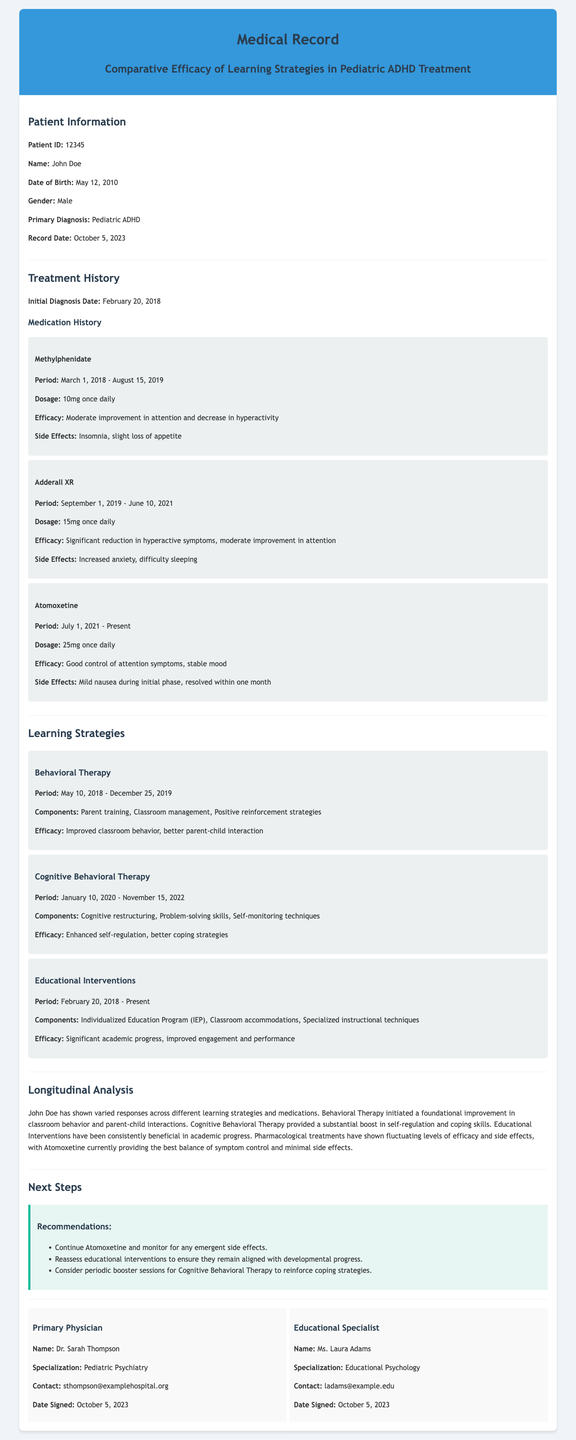What is the patient's name? The patient's name is clearly stated in the document under "Patient Information."
Answer: John Doe What was the primary diagnosis? The primary diagnosis is listed in the "Patient Information" section of the document.
Answer: Pediatric ADHD What medication was taken from March 1, 2018, to August 15, 2019? This can be found in the "Medication History" section that details periods for each medication.
Answer: Methylphenidate What was the efficacy of Adderall XR? The efficacy of Adderall XR is described as per the treatment history provided for that medication.
Answer: Significant reduction in hyperactive symptoms, moderate improvement in attention During which period was Cognitive Behavioral Therapy applied? The period for Cognitive Behavioral Therapy is outlined in the "Learning Strategies" section.
Answer: January 10, 2020 - November 15, 2022 What recommendation was made regarding Atomoxetine? The recommendations for next steps can be found towards the end of the document and specifically mention Atomoxetine.
Answer: Continue Atomoxetine and monitor for any emergent side effects How long did Educational Interventions last? The duration of Educational Interventions can be found in the "Learning Strategies" section.
Answer: February 20, 2018 - Present Who is the primary physician listed? The "Primary Physician" section contains details about the physician responsible for the patient's care.
Answer: Dr. Sarah Thompson 